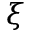Convert formula to latex. <formula><loc_0><loc_0><loc_500><loc_500>\xi</formula> 